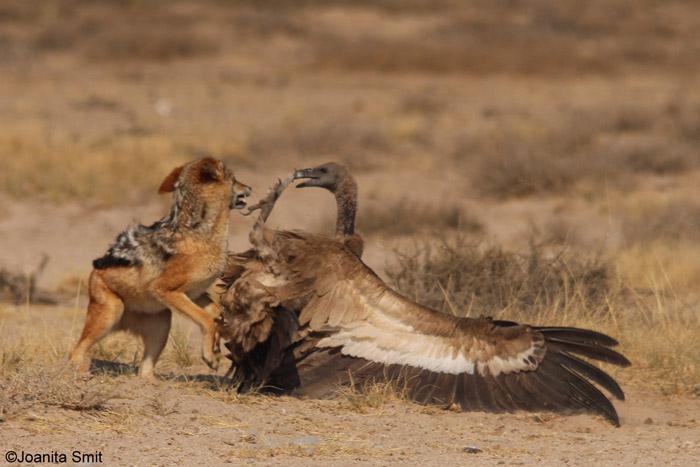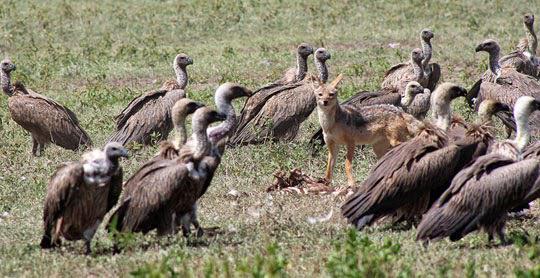The first image is the image on the left, the second image is the image on the right. Analyze the images presented: Is the assertion "There is exactly one brown dog in the image on the left." valid? Answer yes or no. Yes. 